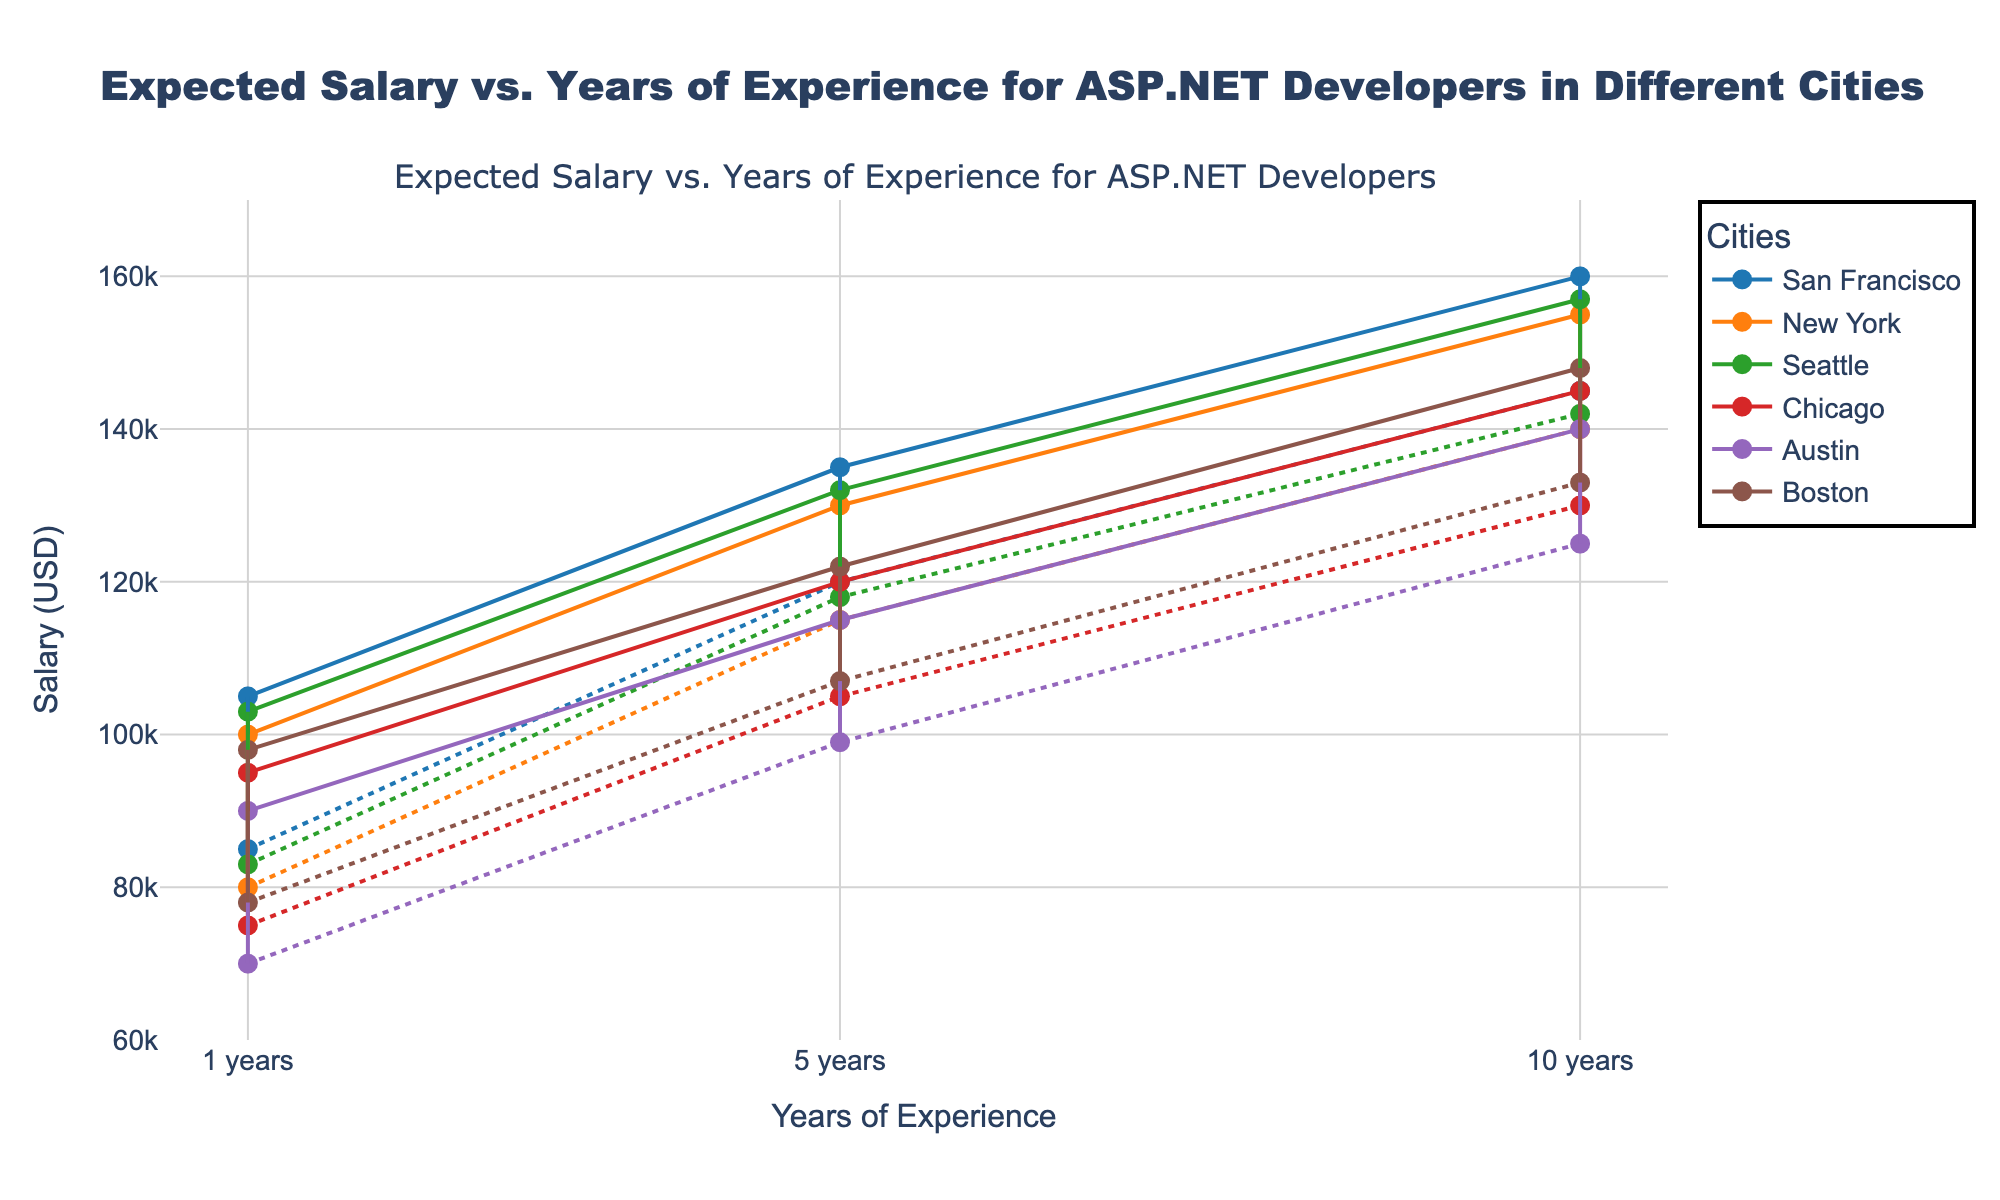What's the title of the plot? The title is placed at the top of the plot and clearly states the purpose of the visualization. It reads: "Expected Salary vs. Years of Experience for ASP.NET Developers in Different Cities."
Answer: Expected Salary vs. Years of Experience for ASP.NET Developers in Different Cities What is the y-axis representing in the plot? The y-axis represents the salary in US dollars as indicated by the label "Salary (USD)." This can be understood by observing the numeric values and the 'USD' annotation.
Answer: Salary (USD) Which city has the highest maximum salary for 10 years of experience? To find this, look at the rightmost data points for the 10 years of experience in all cities. San Francisco shows the highest point on the y-axis compared to the other cities for 10 years of experience.
Answer: San Francisco What are the salaries ranges for ASP.NET developers with 5 years of experience in Seattle? To find this, locate the point at 5 years of experience for the city Seattle. The minimum and maximum salaries are shown by the two endpoints of the dumbbell line, which are $118,000 and $132,000 respectively.
Answer: $118,000 to $132,000 Which city has the widest salary range at 1 year of experience? To determine this, compare the distances between the minimum and maximum salary points (dumbbells) for 1 year of experience across all cities. San Francisco has the widest range as the difference between $85,000 and $105,000 is the greatest among all cities.
Answer: San Francisco What’s the difference in maximum salary between Austin and New York for 5 years of experience? Find the maximum salary points for Austin and New York at 5 years of experience. New York shows $130,000 and Austin shows $115,000. Subtract Austin's maximum salary from New York's to get the difference: $130,000 - $115,000 = $15,000.
Answer: $15,000 On average, which city offers the highest starting salary? Look at the minimum salary points for 1 year of experience across all cities. San Francisco offers the highest minimum starting salary at $85,000. This is determined by visually comparing the lowest points closest to the origin on the y-axis.
Answer: San Francisco Which city's salary range decreases as experience increases from 1 year to 10 years? Compare the length of the dumbbell lines for each experience level across all cities. Austin's salary range decreases significantly from a range of $20,000 at 1 year to a range of $15,000 at 10 years.
Answer: Austin How does the salary trend for Chicago differ from that of Boston over 10 years of experience? For both cities, observe the lines connecting the minimum and maximum salary points over the years. While both show increases, Chicago’s salary range increases by $55,000 from 1 year to 10 years, compared to Boston's $50,000 increase, and the two city's maximum salaries differ significantly with Chicago lower overall.
Answer: Chicago’s salary range widens more, but Boston offers higher salaries 